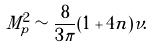<formula> <loc_0><loc_0><loc_500><loc_500>M _ { p } ^ { 2 } \sim \frac { 8 } { 3 \pi } ( 1 + 4 n ) \nu .</formula> 